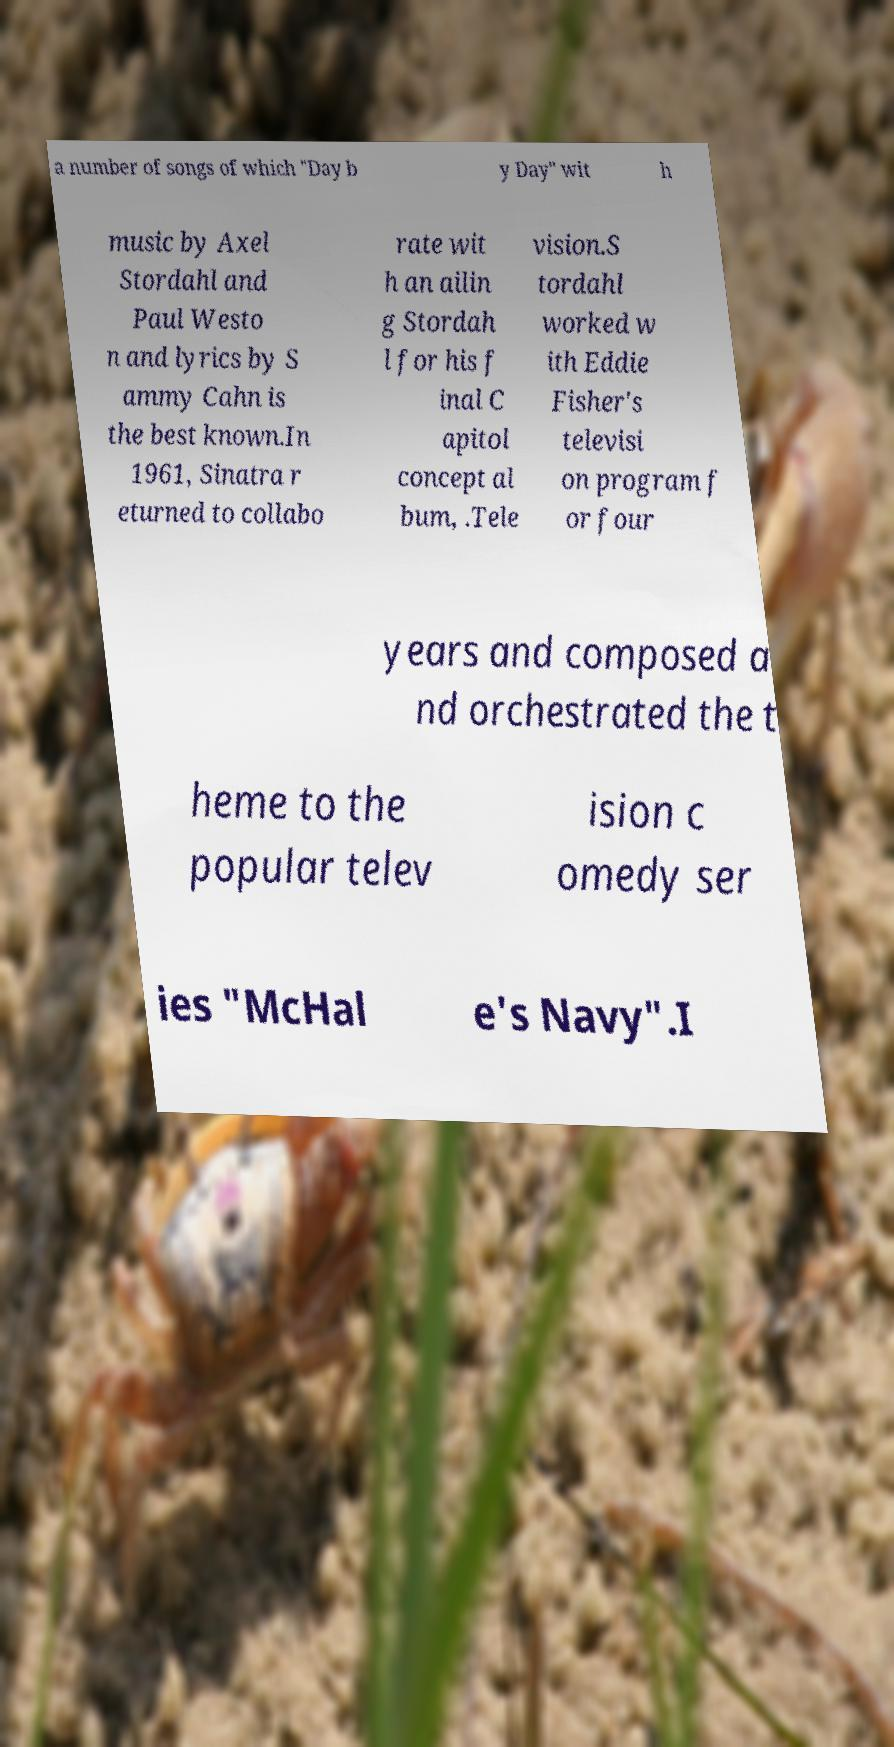There's text embedded in this image that I need extracted. Can you transcribe it verbatim? a number of songs of which "Day b y Day" wit h music by Axel Stordahl and Paul Westo n and lyrics by S ammy Cahn is the best known.In 1961, Sinatra r eturned to collabo rate wit h an ailin g Stordah l for his f inal C apitol concept al bum, .Tele vision.S tordahl worked w ith Eddie Fisher's televisi on program f or four years and composed a nd orchestrated the t heme to the popular telev ision c omedy ser ies "McHal e's Navy".I 